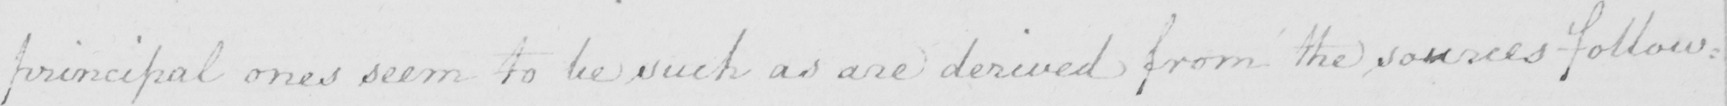What does this handwritten line say? principal ones seem to be such as are derived from the sources follow= 